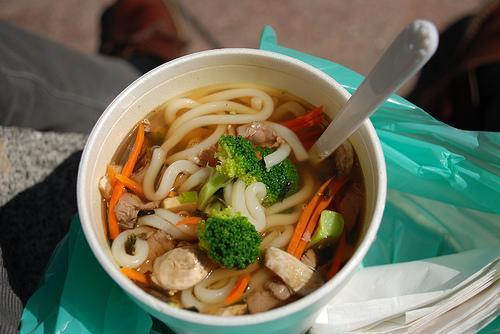How many bowls are there?
Give a very brief answer. 1. 